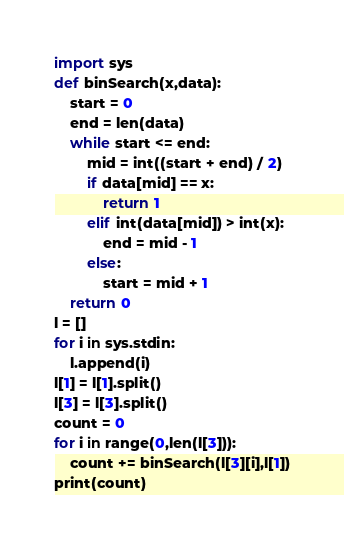Convert code to text. <code><loc_0><loc_0><loc_500><loc_500><_Python_>import sys
def binSearch(x,data):
    start = 0
    end = len(data)
    while start <= end:
        mid = int((start + end) / 2)
        if data[mid] == x:
            return 1
        elif int(data[mid]) > int(x):
            end = mid - 1
        else:
            start = mid + 1
    return 0
l = []
for i in sys.stdin:
    l.append(i)
l[1] = l[1].split()
l[3] = l[3].split()
count = 0
for i in range(0,len(l[3])):
    count += binSearch(l[3][i],l[1])
print(count)
</code> 